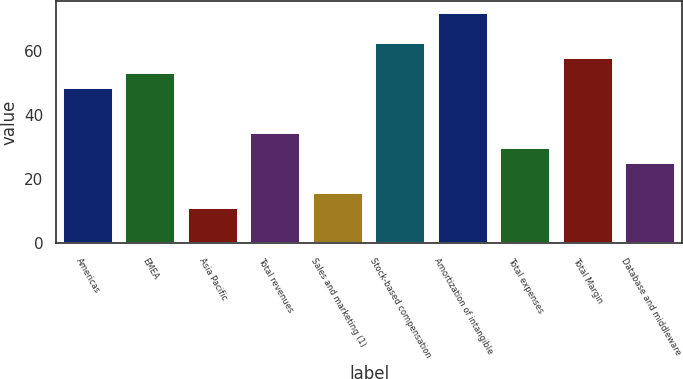Convert chart. <chart><loc_0><loc_0><loc_500><loc_500><bar_chart><fcel>Americas<fcel>EMEA<fcel>Asia Pacific<fcel>Total revenues<fcel>Sales and marketing (1)<fcel>Stock-based compensation<fcel>Amortization of intangible<fcel>Total expenses<fcel>Total Margin<fcel>Database and middleware<nl><fcel>48.6<fcel>53.3<fcel>11<fcel>34.5<fcel>15.7<fcel>62.7<fcel>72.1<fcel>29.8<fcel>58<fcel>25.1<nl></chart> 